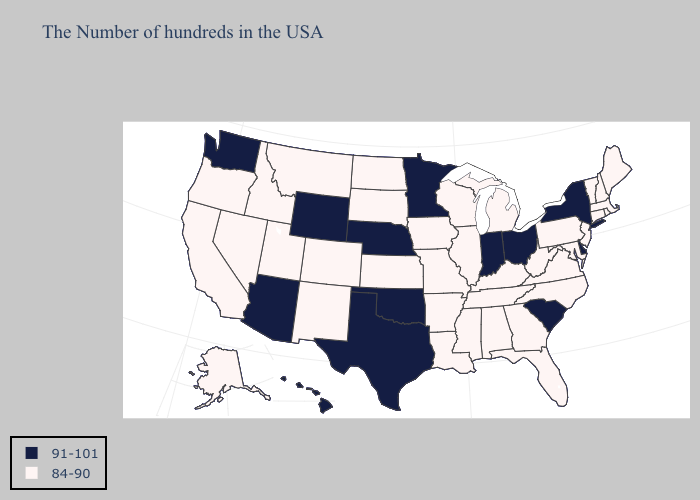Does South Carolina have the lowest value in the USA?
Short answer required. No. What is the lowest value in the USA?
Answer briefly. 84-90. Does New Jersey have the highest value in the Northeast?
Quick response, please. No. Which states have the lowest value in the Northeast?
Give a very brief answer. Maine, Massachusetts, Rhode Island, New Hampshire, Vermont, Connecticut, New Jersey, Pennsylvania. Does Vermont have the highest value in the USA?
Write a very short answer. No. Name the states that have a value in the range 84-90?
Give a very brief answer. Maine, Massachusetts, Rhode Island, New Hampshire, Vermont, Connecticut, New Jersey, Maryland, Pennsylvania, Virginia, North Carolina, West Virginia, Florida, Georgia, Michigan, Kentucky, Alabama, Tennessee, Wisconsin, Illinois, Mississippi, Louisiana, Missouri, Arkansas, Iowa, Kansas, South Dakota, North Dakota, Colorado, New Mexico, Utah, Montana, Idaho, Nevada, California, Oregon, Alaska. Does Utah have the same value as Arizona?
Short answer required. No. Which states have the highest value in the USA?
Concise answer only. New York, Delaware, South Carolina, Ohio, Indiana, Minnesota, Nebraska, Oklahoma, Texas, Wyoming, Arizona, Washington, Hawaii. Does New York have the highest value in the Northeast?
Short answer required. Yes. Does Alabama have the lowest value in the South?
Write a very short answer. Yes. What is the value of North Carolina?
Short answer required. 84-90. Name the states that have a value in the range 91-101?
Keep it brief. New York, Delaware, South Carolina, Ohio, Indiana, Minnesota, Nebraska, Oklahoma, Texas, Wyoming, Arizona, Washington, Hawaii. What is the highest value in the USA?
Keep it brief. 91-101. How many symbols are there in the legend?
Be succinct. 2. 